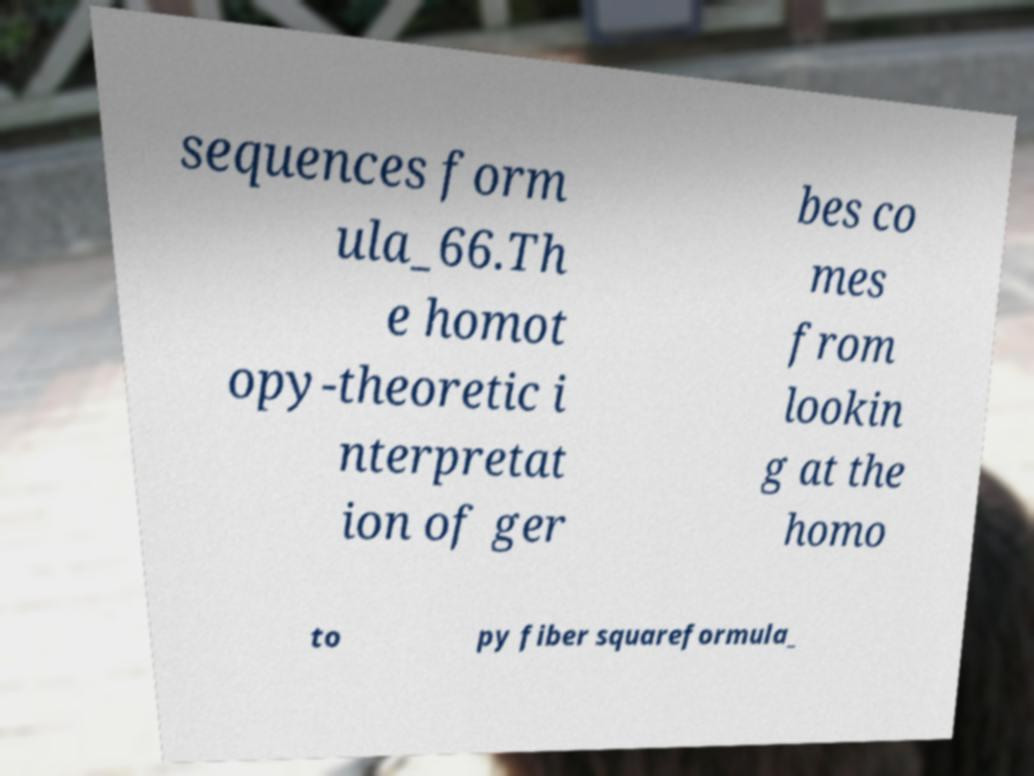What messages or text are displayed in this image? I need them in a readable, typed format. sequences form ula_66.Th e homot opy-theoretic i nterpretat ion of ger bes co mes from lookin g at the homo to py fiber squareformula_ 